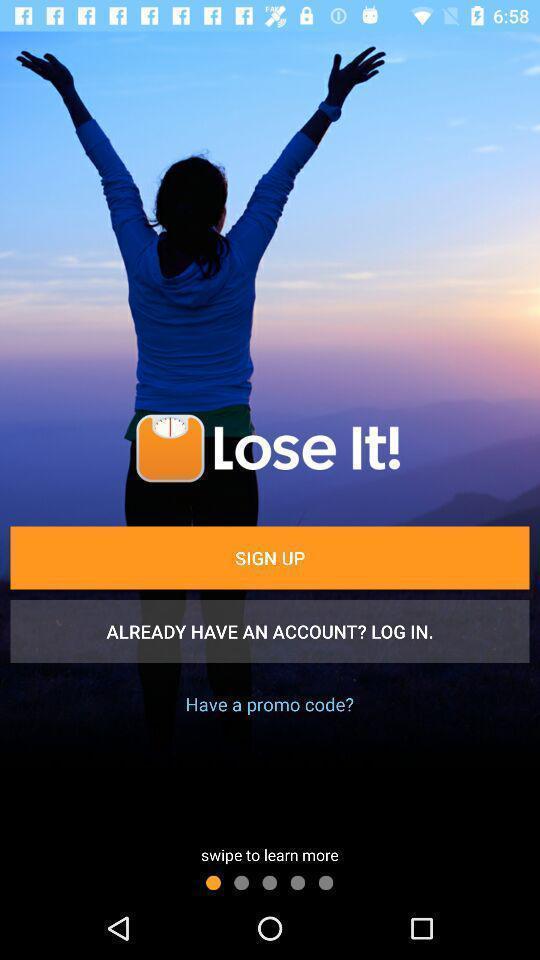What can you discern from this picture? Welcome page of a food app. 